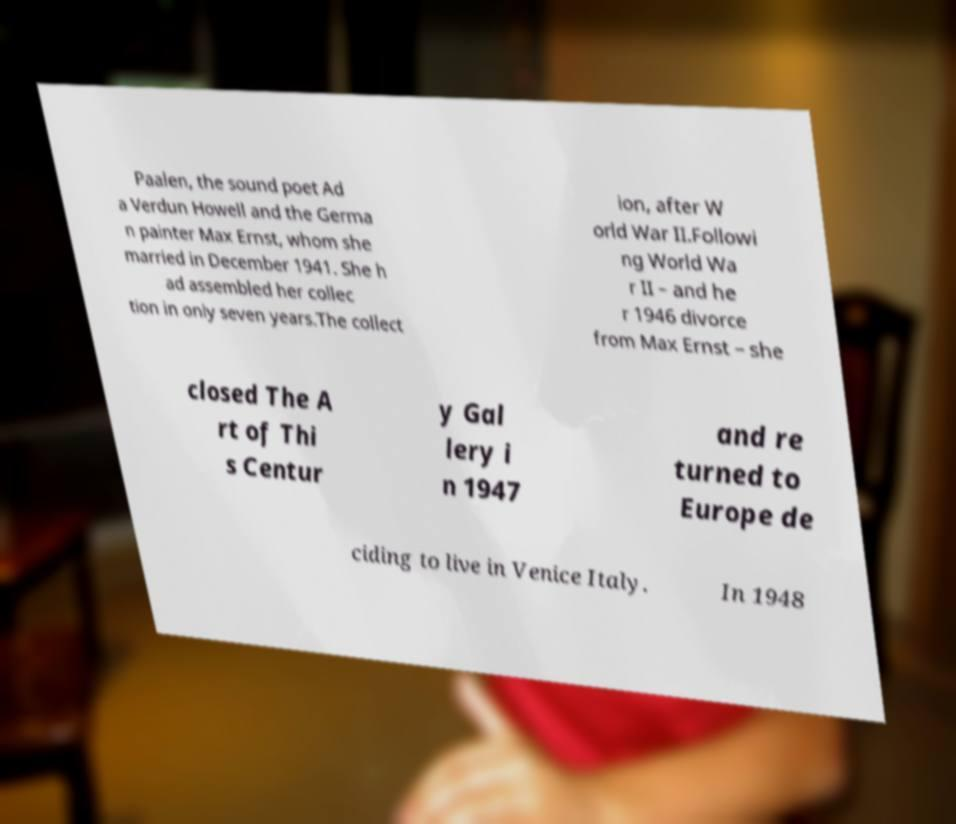There's text embedded in this image that I need extracted. Can you transcribe it verbatim? Paalen, the sound poet Ad a Verdun Howell and the Germa n painter Max Ernst, whom she married in December 1941. She h ad assembled her collec tion in only seven years.The collect ion, after W orld War II.Followi ng World Wa r II – and he r 1946 divorce from Max Ernst – she closed The A rt of Thi s Centur y Gal lery i n 1947 and re turned to Europe de ciding to live in Venice Italy. In 1948 